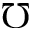Convert formula to latex. <formula><loc_0><loc_0><loc_500><loc_500>\mho</formula> 